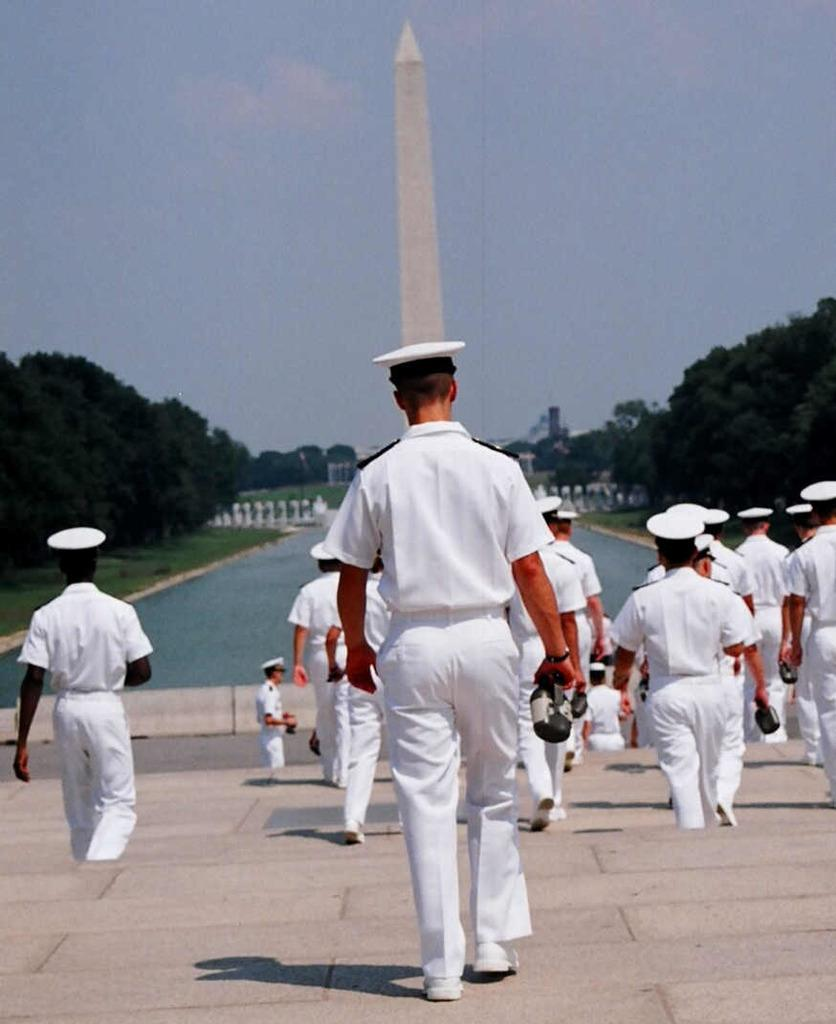How many people are in the image? There is a group of persons in the image. What are the people in the image doing? The group of persons is walking on stairs. What can be seen in the background of the image? There is a tower, trees, water, and the sky visible in the background of the image. How many babies are visible in the image? There are no babies present in the image. What type of poison is being used by the people in the image? There is no mention of poison or any dangerous substances in the image. 